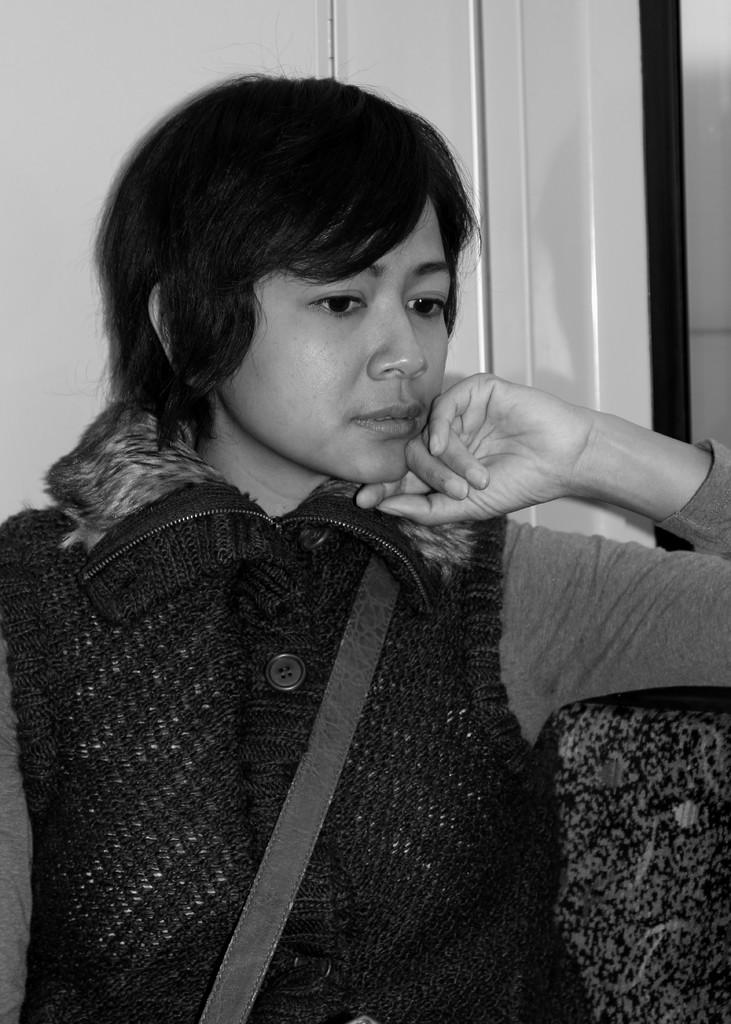Who or what is present in the image? There is a person in the image. What is the person doing in the image? The person is sitting on a chair. What can be seen in the background of the image? There is a wall visible in the background of the image. What type of toothpaste is the person using in the image? There is no toothpaste present in the image; it only shows a person sitting on a chair with a wall in the background. 